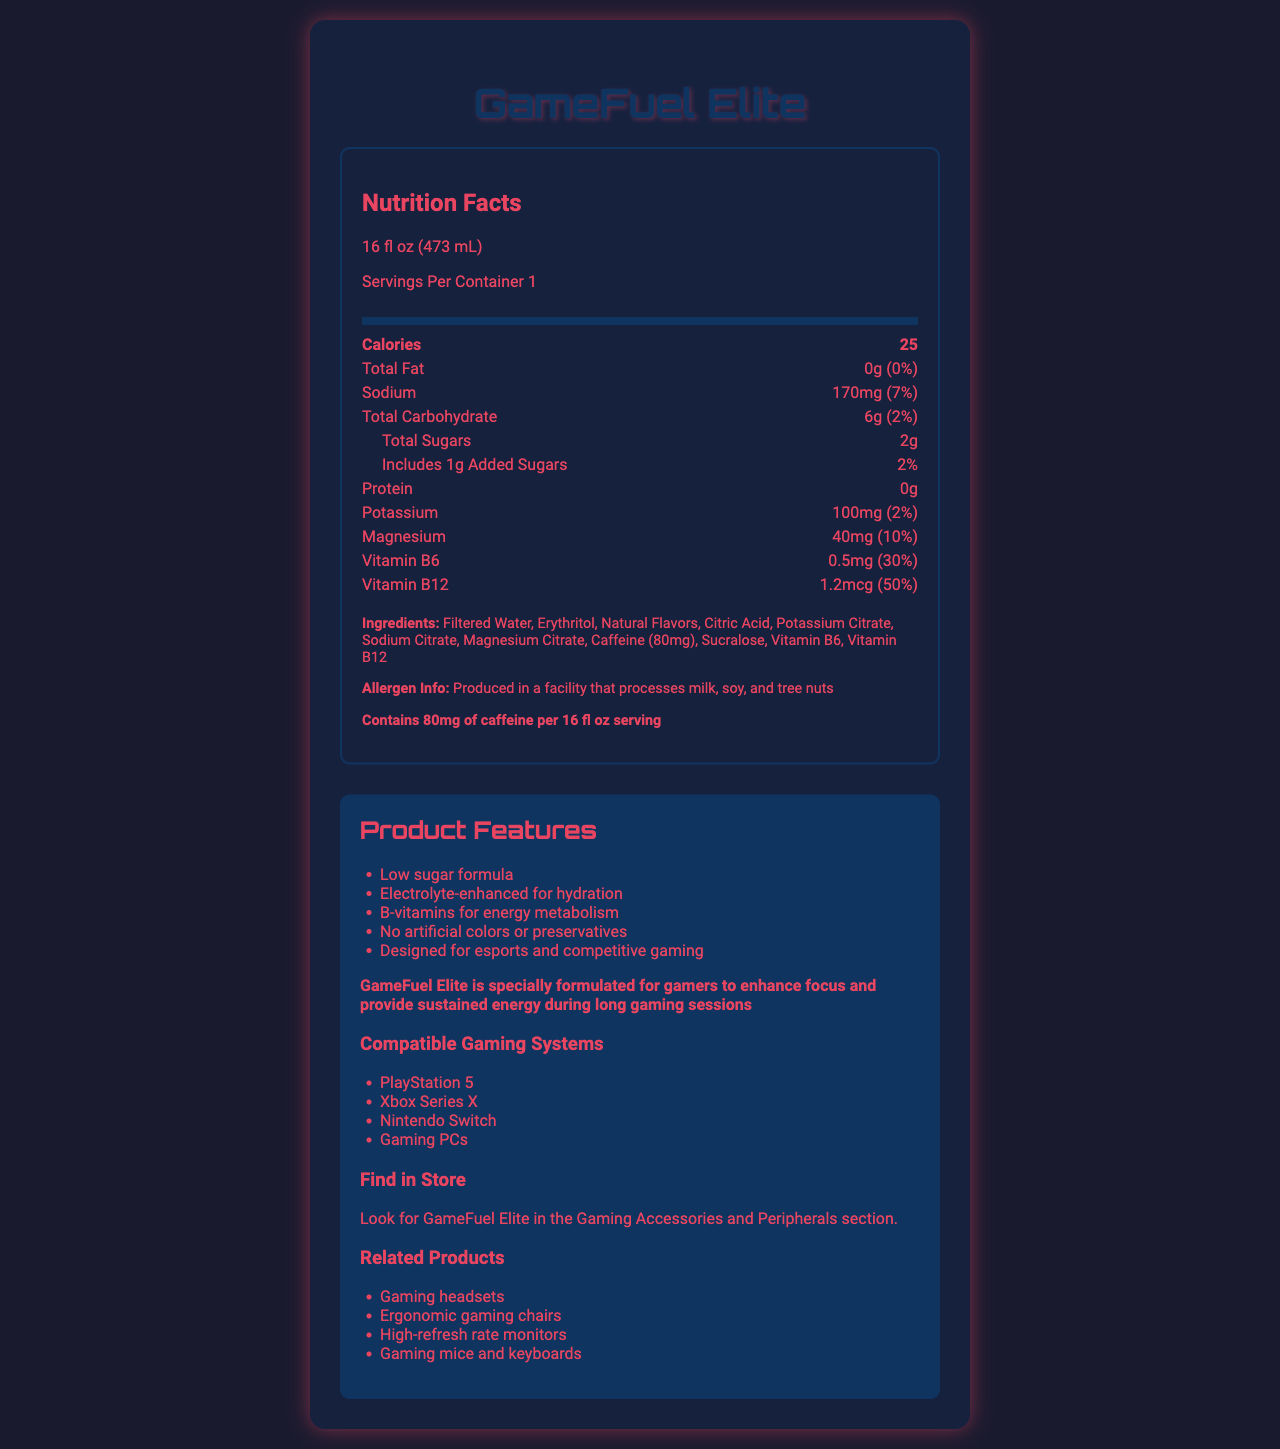what is the serving size of GameFuel Elite? The serving size is clearly stated in the document as 16 fl oz (473 mL).
Answer: 16 fl oz (473 mL) how many calories does one serving of GameFuel Elite contain? The document mentions that one serving contains 25 calories.
Answer: 25 what is the amount of sodium in GameFuel Elite and its daily value percentage? The document states that there are 170mg of sodium per serving, which is 7% of the daily value.
Answer: 170mg, 7% how much protein is in a serving of GameFuel Elite? The document clearly states that there is no protein in GameFuel Elite.
Answer: 0g which ingredients in GameFuel Elite are vitamins? The ingredients list includes Vitamin B6 and Vitamin B12 as components.
Answer: Vitamin B6, Vitamin B12 which ingredient in GameFuel Elite is associated with providing caffeine? The ingredients list mentions "Caffeine (80mg)" specifically.
Answer: Caffeine (80mg) how is GameFuel Elite particularly designed for gamers? A. It contains high sugar B. It has no caffeine C. It enhances focus and provides sustained energy The brand statement says, "GameFuel Elite is specially formulated for gamers to enhance focus and provide sustained energy during long gaming sessions."
Answer: C which of the following is NOT a feature of GameFuel Elite? A. Low sugar formula B. Artificial colors C. Electrolyte-enhanced for hydration The document specifies that GameFuel Elite has no artificial colors or preservatives.
Answer: B is GameFuel Elite compatible with Xbox Series X? The document lists Xbox Series X among the compatible gaming systems.
Answer: Yes does GameFuel Elite contain more than 200mg of sodium? The document lists the sodium content as 170mg, which is less than 200mg.
Answer: No summarize the nutrition facts and product details of GameFuel Elite. The document provides detailed nutritional information, ingredient list, and various product features, including its specific design for gamers and its placement in the store.
Answer: GameFuel Elite is a 16 fl oz low-sugar beverage with 25 calories per serving. It has 0g fat, 170mg sodium (7% DV), 6g carbohydrates (2% DV) including 2g sugars (1g added sugars, 2% DV), 0g protein, 100mg potassium (2% DV), 40mg magnesium (10% DV), 0.5mg Vitamin B6 (30% DV), and 1.2mcg Vitamin B12 (50% DV). Ingredients include filtered water, erythritol, natural flavors, citric acid, potassium citrate, sodium citrate, magnesium citrate, caffeine (80mg), sucralose, Vitamin B6, and Vitamin B12. The product is designed for gamers, enhancing focus and energy, and is placed in the Gaming Accessories and Peripherals section of the store. what is the main source of sweetness in GameFuel Elite? The document lists both erythritol and sucralose as sweeteners, but does not specify which is the main source.
Answer: Cannot be determined what is the total carbohydrate content per serving? The document lists the total carbohydrate content as 6g per serving.
Answer: 6g 